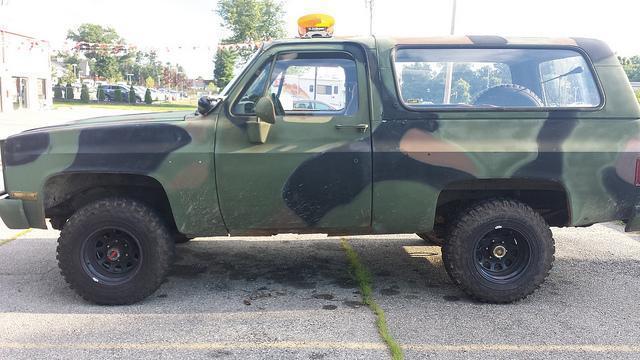What style of paint is on this vehicle?
From the following four choices, select the correct answer to address the question.
Options: Graffiti, spray, watercolor, camo. Camo. 